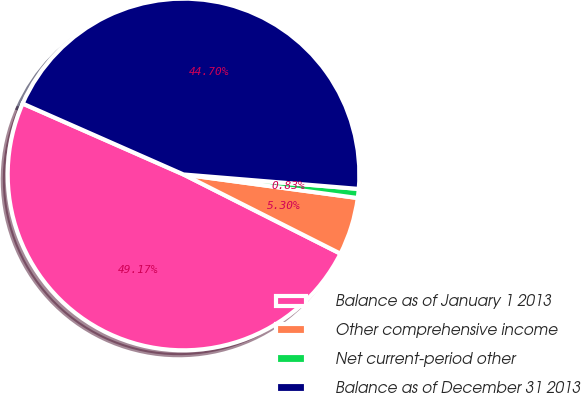Convert chart. <chart><loc_0><loc_0><loc_500><loc_500><pie_chart><fcel>Balance as of January 1 2013<fcel>Other comprehensive income<fcel>Net current-period other<fcel>Balance as of December 31 2013<nl><fcel>49.17%<fcel>5.3%<fcel>0.83%<fcel>44.7%<nl></chart> 